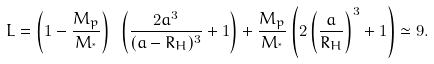<formula> <loc_0><loc_0><loc_500><loc_500>L = \left ( 1 - \frac { M _ { p } } { M _ { ^ { * } } } \right ) \ \left ( \frac { 2 a ^ { 3 } } { ( a - R _ { H } ) ^ { 3 } } + 1 \right ) + \frac { M _ { p } } { M _ { ^ { * } } } \left ( 2 \left ( \frac { a } { R _ { H } } \right ) ^ { 3 } + 1 \right ) \simeq 9 .</formula> 